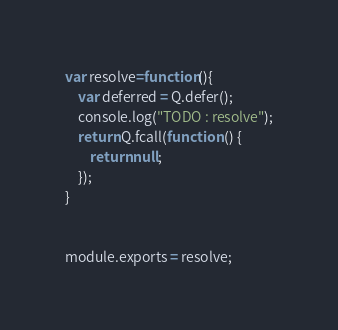Convert code to text. <code><loc_0><loc_0><loc_500><loc_500><_JavaScript_>var resolve=function(){
	var deferred = Q.defer();
	console.log("TODO : resolve");
	return Q.fcall(function () {
	    return null;
	});
}


module.exports = resolve;</code> 